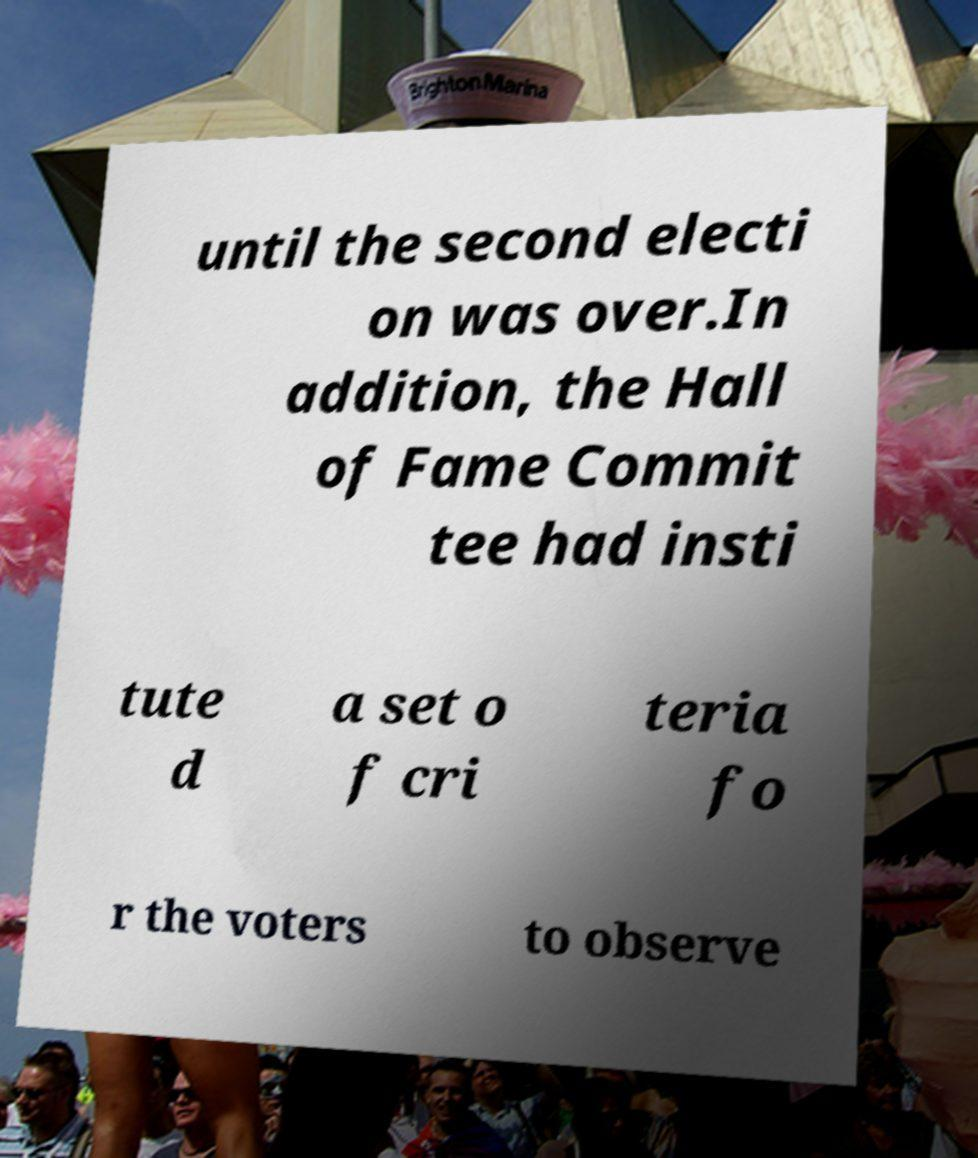Can you accurately transcribe the text from the provided image for me? until the second electi on was over.In addition, the Hall of Fame Commit tee had insti tute d a set o f cri teria fo r the voters to observe 